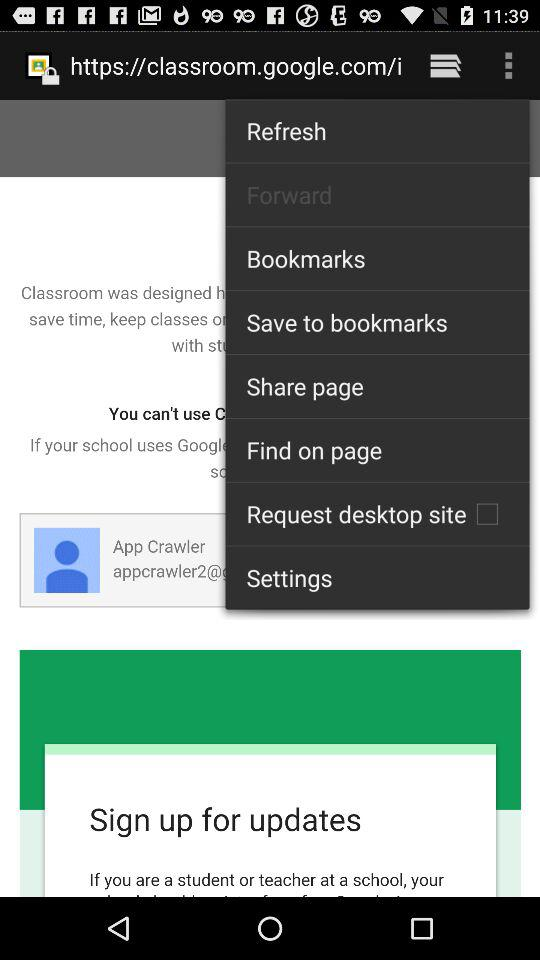Which application page is opened?
When the provided information is insufficient, respond with <no answer>. <no answer> 